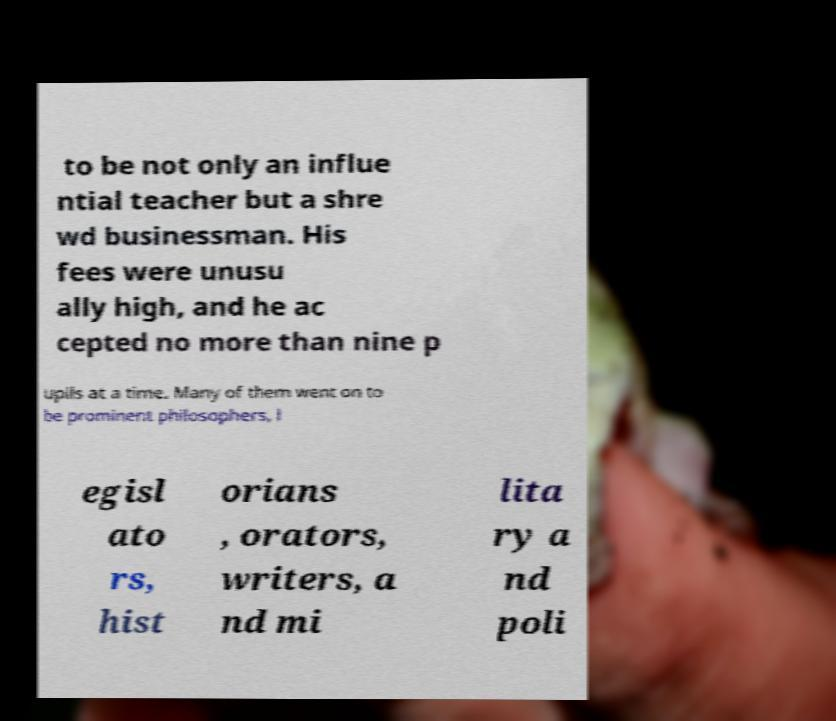Can you read and provide the text displayed in the image?This photo seems to have some interesting text. Can you extract and type it out for me? to be not only an influe ntial teacher but a shre wd businessman. His fees were unusu ally high, and he ac cepted no more than nine p upils at a time. Many of them went on to be prominent philosophers, l egisl ato rs, hist orians , orators, writers, a nd mi lita ry a nd poli 